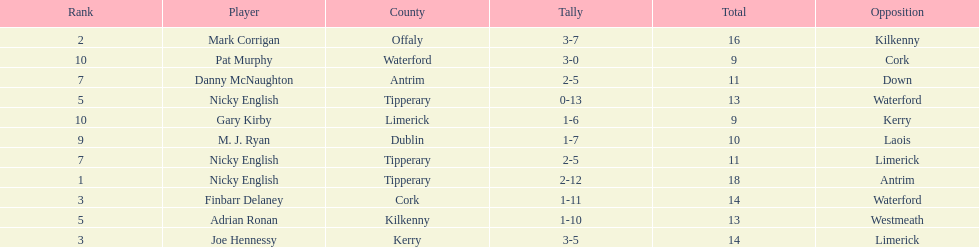How many times was waterford the opposition? 2. 